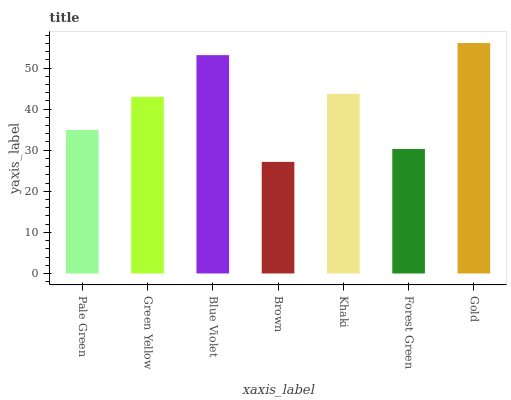Is Brown the minimum?
Answer yes or no. Yes. Is Gold the maximum?
Answer yes or no. Yes. Is Green Yellow the minimum?
Answer yes or no. No. Is Green Yellow the maximum?
Answer yes or no. No. Is Green Yellow greater than Pale Green?
Answer yes or no. Yes. Is Pale Green less than Green Yellow?
Answer yes or no. Yes. Is Pale Green greater than Green Yellow?
Answer yes or no. No. Is Green Yellow less than Pale Green?
Answer yes or no. No. Is Green Yellow the high median?
Answer yes or no. Yes. Is Green Yellow the low median?
Answer yes or no. Yes. Is Brown the high median?
Answer yes or no. No. Is Khaki the low median?
Answer yes or no. No. 